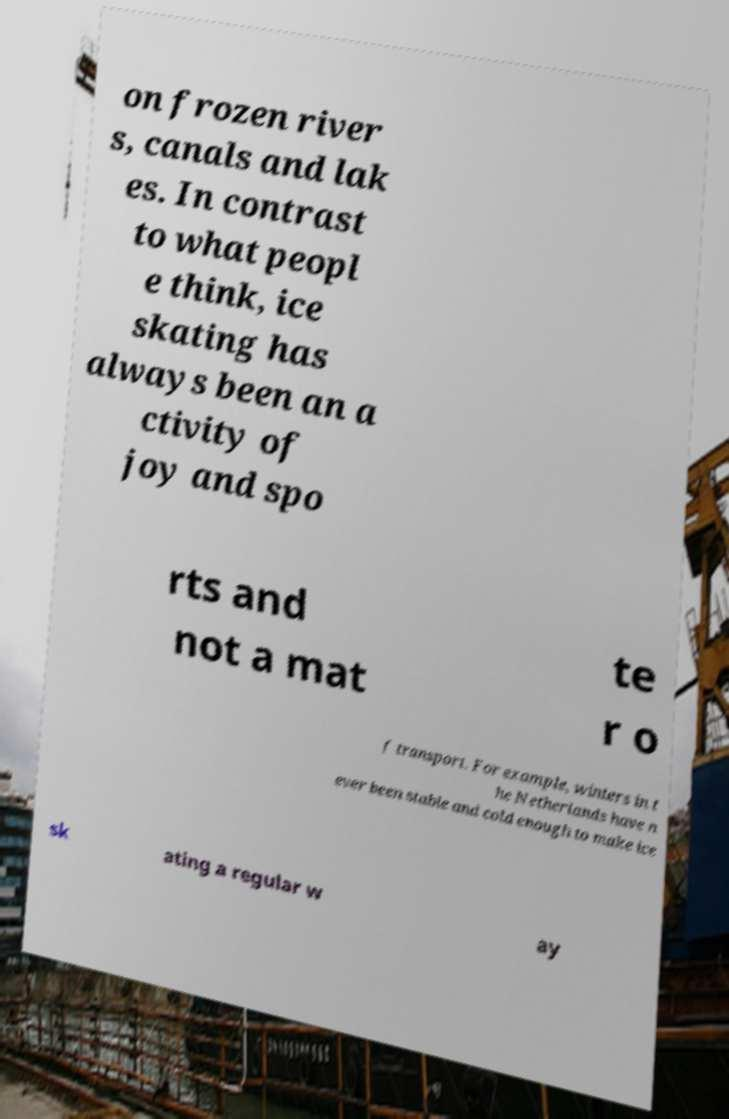Please read and relay the text visible in this image. What does it say? on frozen river s, canals and lak es. In contrast to what peopl e think, ice skating has always been an a ctivity of joy and spo rts and not a mat te r o f transport. For example, winters in t he Netherlands have n ever been stable and cold enough to make ice sk ating a regular w ay 